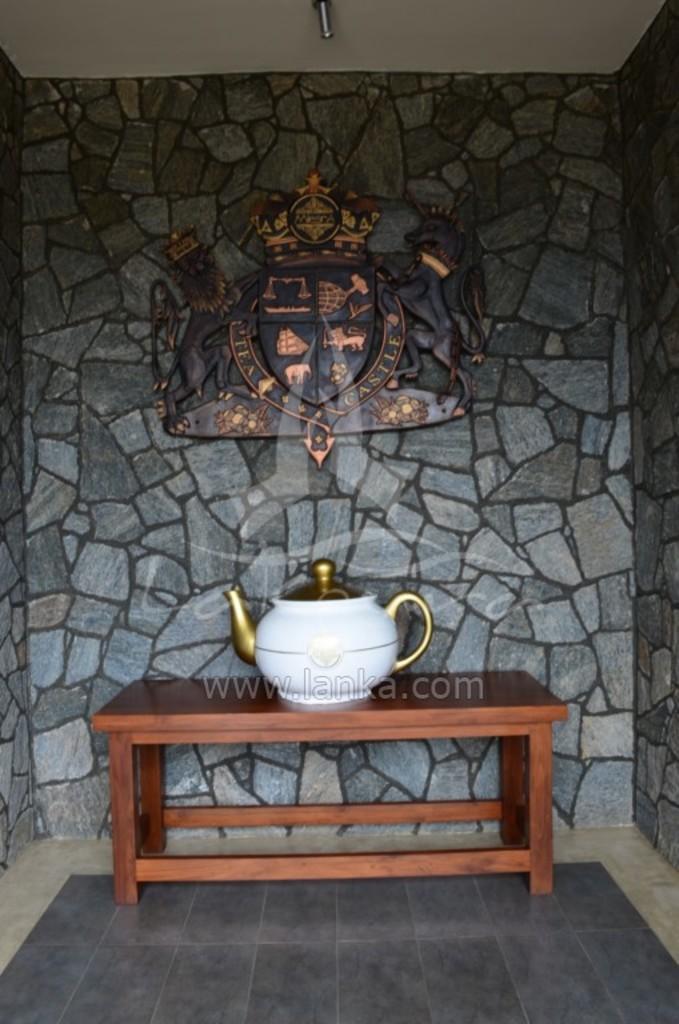Could you give a brief overview of what you see in this image? This is table. On the table there is a kettle. This is floor and there is a wall. On the wall there is a shield. 